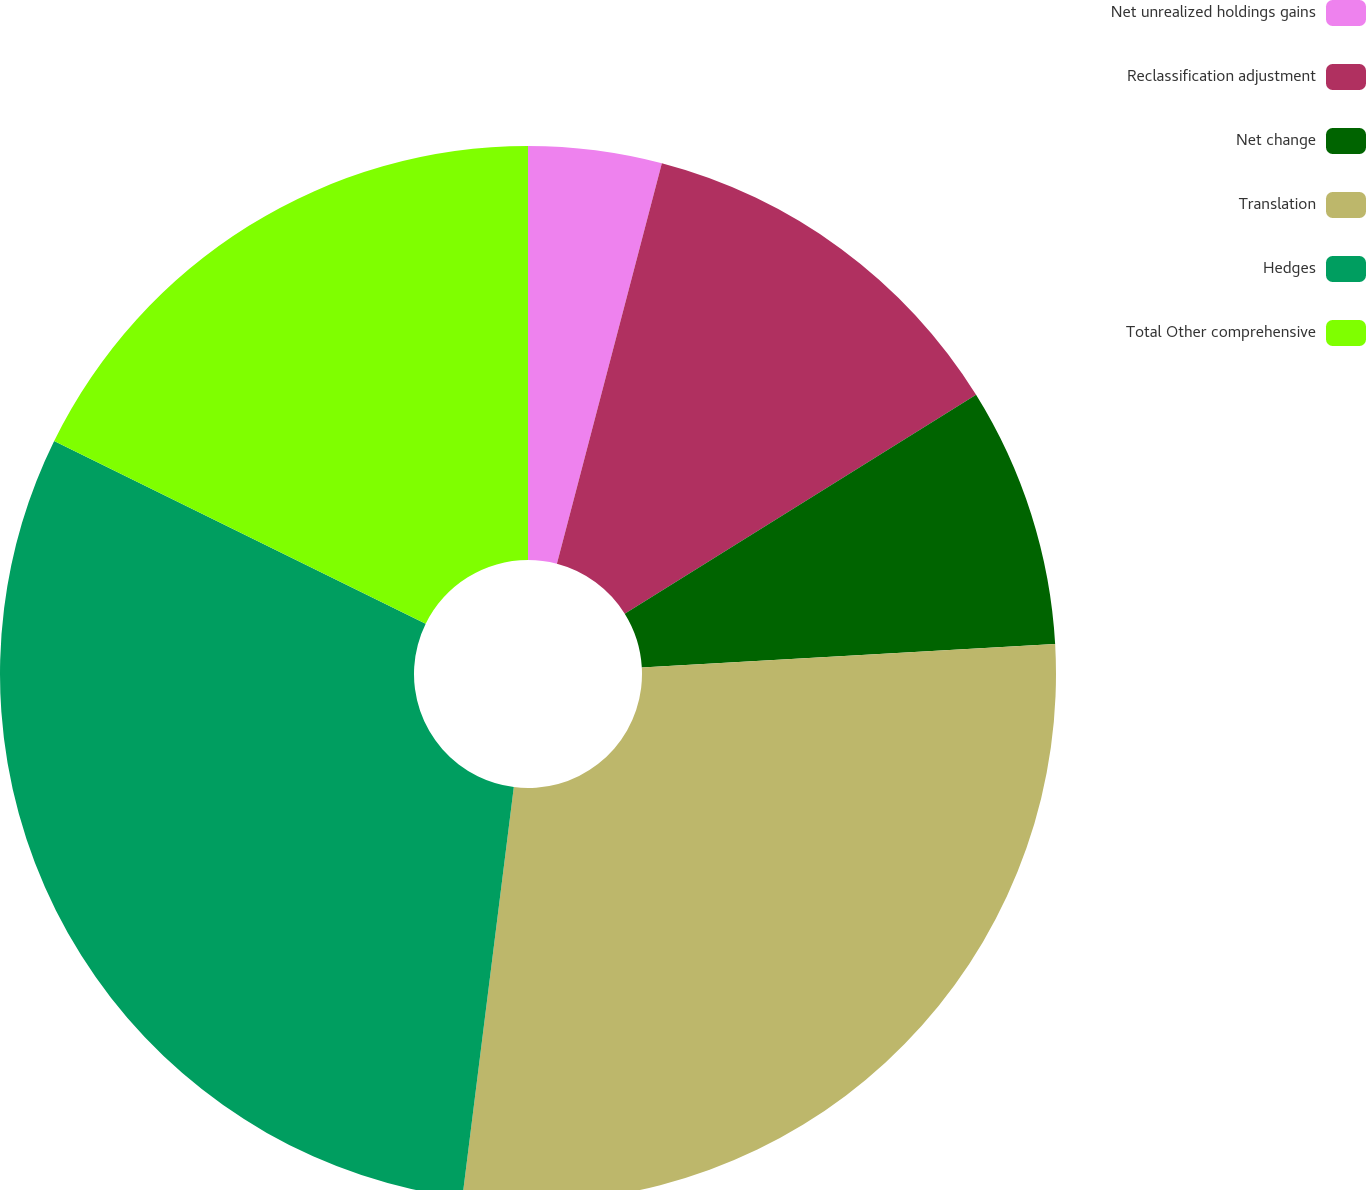Convert chart. <chart><loc_0><loc_0><loc_500><loc_500><pie_chart><fcel>Net unrealized holdings gains<fcel>Reclassification adjustment<fcel>Net change<fcel>Translation<fcel>Hedges<fcel>Total Other comprehensive<nl><fcel>4.08%<fcel>12.05%<fcel>7.97%<fcel>27.89%<fcel>30.29%<fcel>17.73%<nl></chart> 